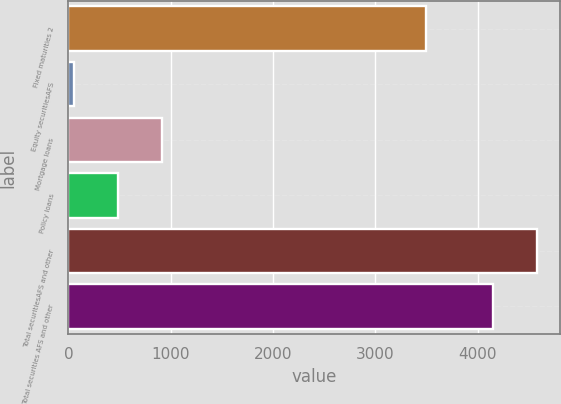Convert chart to OTSL. <chart><loc_0><loc_0><loc_500><loc_500><bar_chart><fcel>Fixed maturities 2<fcel>Equity securitiesAFS<fcel>Mortgage loans<fcel>Policy loans<fcel>Total securitiesAFS and other<fcel>Total securities AFS and other<nl><fcel>3489<fcel>53<fcel>915.2<fcel>484.1<fcel>4579.1<fcel>4148<nl></chart> 